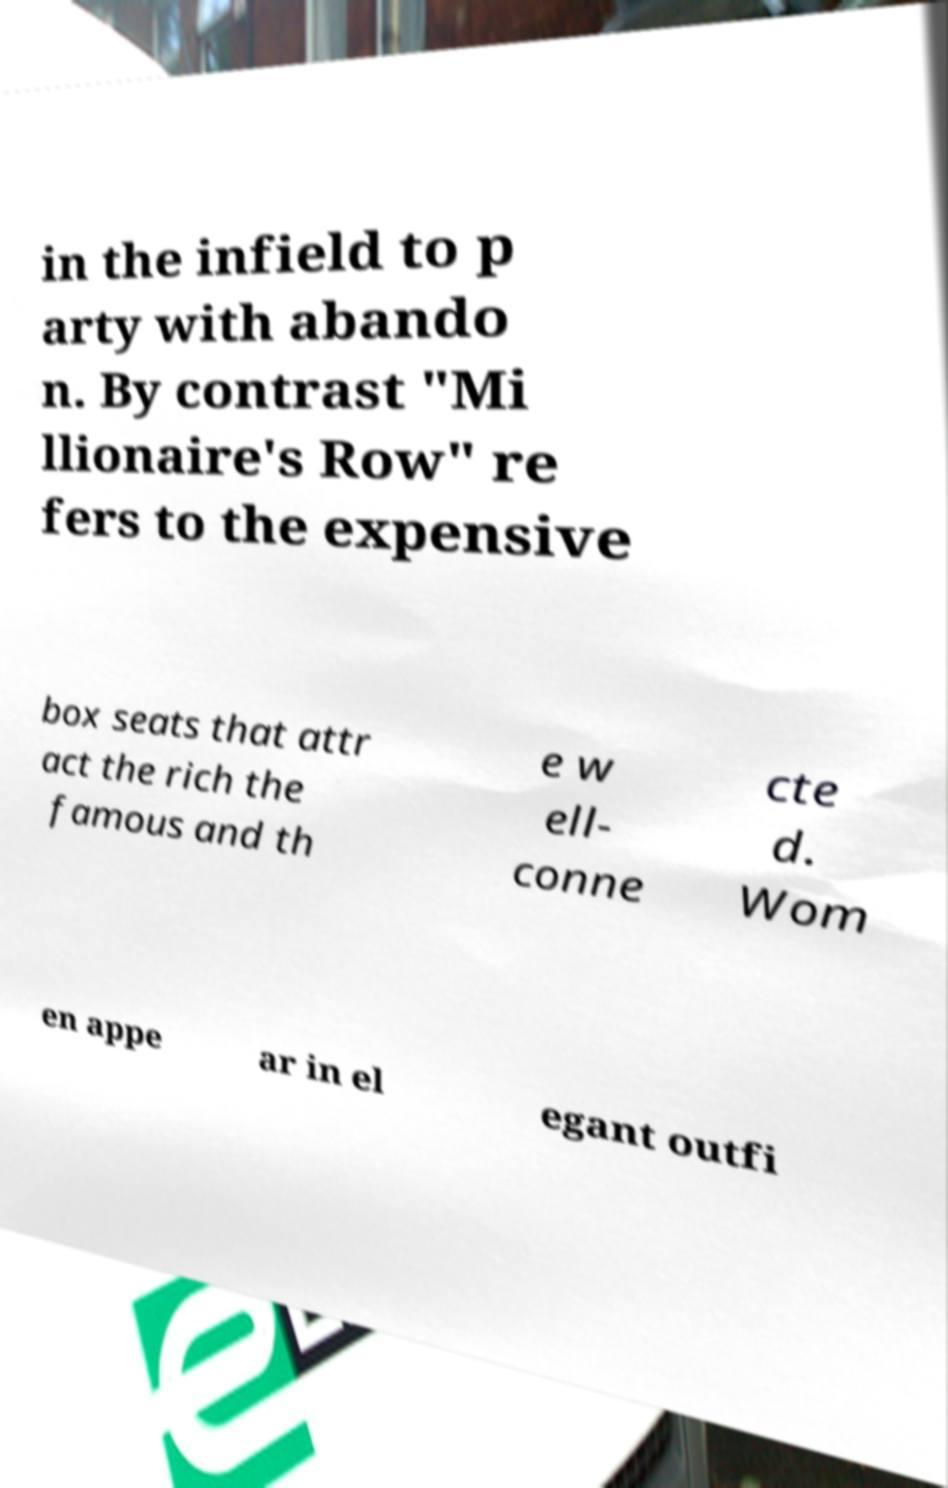There's text embedded in this image that I need extracted. Can you transcribe it verbatim? in the infield to p arty with abando n. By contrast "Mi llionaire's Row" re fers to the expensive box seats that attr act the rich the famous and th e w ell- conne cte d. Wom en appe ar in el egant outfi 